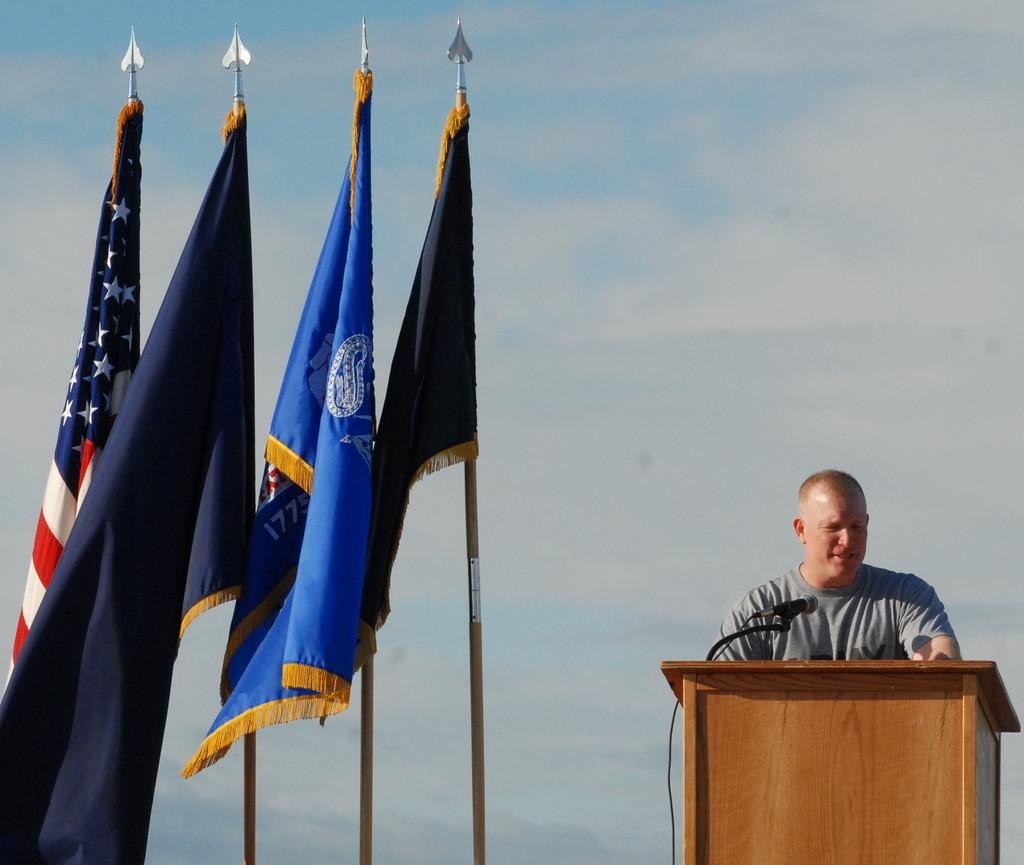What is the person in the image doing? The person is standing. What is in front of the person? There is a podium with a mic in front of the person. What can be seen in the background of the image? There are flags in the image. What other object is present in the image? There is a pole in the image. What type of soup is being served at the event in the image? There is no indication of soup or an event in the image. How many babies are visible in the image? There are no babies present in the image. 